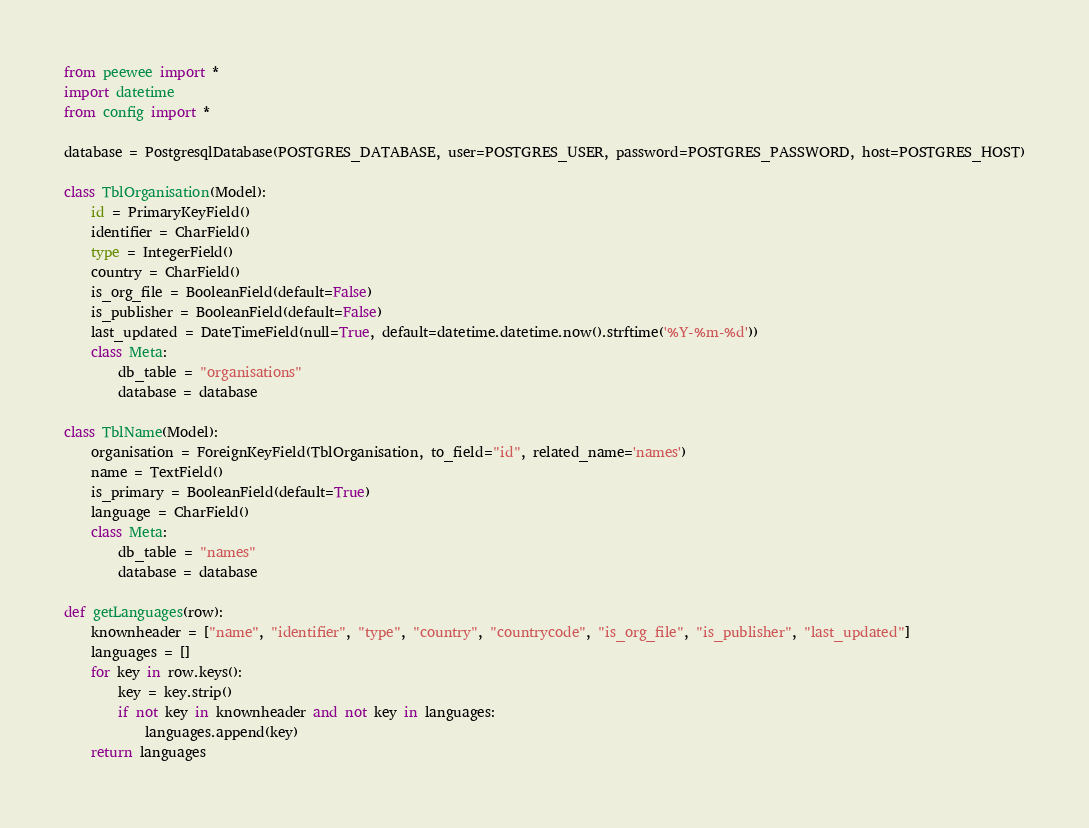<code> <loc_0><loc_0><loc_500><loc_500><_Python_>from peewee import *
import datetime
from config import *

database = PostgresqlDatabase(POSTGRES_DATABASE, user=POSTGRES_USER, password=POSTGRES_PASSWORD, host=POSTGRES_HOST)

class TblOrganisation(Model):
    id = PrimaryKeyField()
    identifier = CharField()
    type = IntegerField()
    country = CharField()
    is_org_file = BooleanField(default=False)
    is_publisher = BooleanField(default=False)
    last_updated = DateTimeField(null=True, default=datetime.datetime.now().strftime('%Y-%m-%d'))
    class Meta:
        db_table = "organisations"
        database = database

class TblName(Model):
    organisation = ForeignKeyField(TblOrganisation, to_field="id", related_name='names')
    name = TextField()
    is_primary = BooleanField(default=True)
    language = CharField()
    class Meta:
        db_table = "names"
        database = database

def getLanguages(row):
    knownheader = ["name", "identifier", "type", "country", "countrycode", "is_org_file", "is_publisher", "last_updated"]
    languages = []
    for key in row.keys():
        key = key.strip()
        if not key in knownheader and not key in languages:
            languages.append(key)
    return languages
</code> 